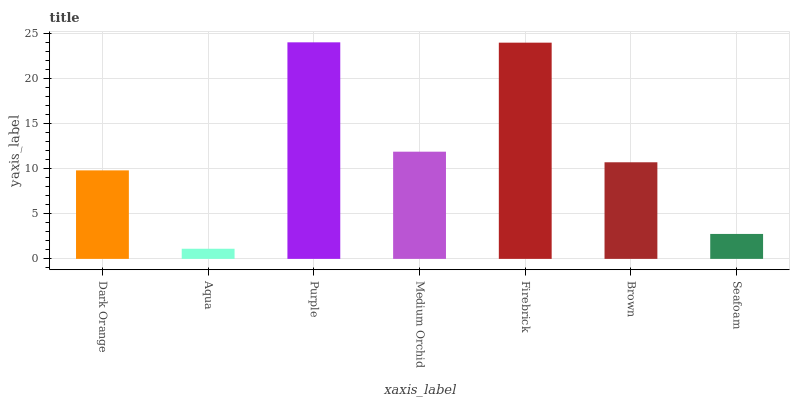Is Purple the minimum?
Answer yes or no. No. Is Aqua the maximum?
Answer yes or no. No. Is Purple greater than Aqua?
Answer yes or no. Yes. Is Aqua less than Purple?
Answer yes or no. Yes. Is Aqua greater than Purple?
Answer yes or no. No. Is Purple less than Aqua?
Answer yes or no. No. Is Brown the high median?
Answer yes or no. Yes. Is Brown the low median?
Answer yes or no. Yes. Is Purple the high median?
Answer yes or no. No. Is Aqua the low median?
Answer yes or no. No. 